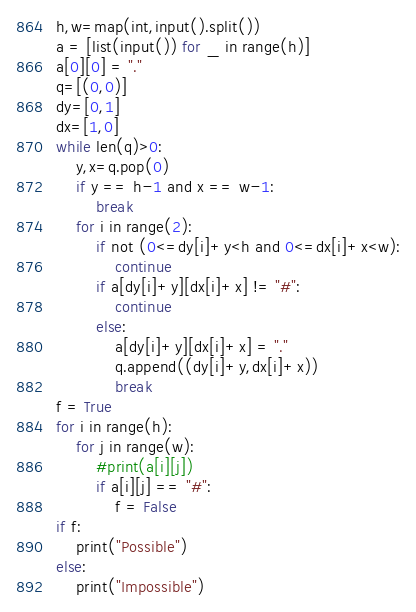<code> <loc_0><loc_0><loc_500><loc_500><_Python_>h,w=map(int,input().split())
a = [list(input()) for _ in range(h)]
a[0][0] = "."
q=[(0,0)]
dy=[0,1]
dx=[1,0]
while len(q)>0:
    y,x=q.pop(0)
    if y == h-1 and x == w-1:
        break
    for i in range(2):
        if not (0<=dy[i]+y<h and 0<=dx[i]+x<w):
            continue
        if a[dy[i]+y][dx[i]+x] != "#":
            continue
        else:
            a[dy[i]+y][dx[i]+x] = "."
            q.append((dy[i]+y,dx[i]+x))
            break
f = True
for i in range(h):
    for j in range(w):
        #print(a[i][j])
        if a[i][j] == "#":
            f = False
if f:
    print("Possible")
else:
    print("Impossible")</code> 